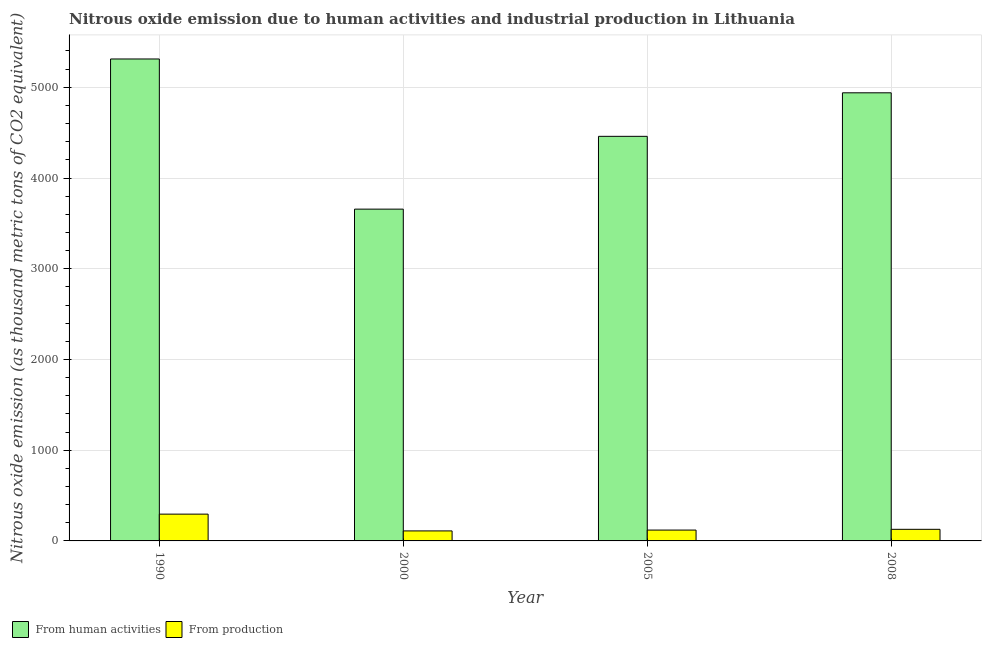How many different coloured bars are there?
Your response must be concise. 2. Are the number of bars per tick equal to the number of legend labels?
Offer a very short reply. Yes. How many bars are there on the 4th tick from the left?
Ensure brevity in your answer.  2. What is the label of the 4th group of bars from the left?
Give a very brief answer. 2008. In how many cases, is the number of bars for a given year not equal to the number of legend labels?
Give a very brief answer. 0. What is the amount of emissions generated from industries in 1990?
Offer a very short reply. 295.2. Across all years, what is the maximum amount of emissions from human activities?
Ensure brevity in your answer.  5312.1. Across all years, what is the minimum amount of emissions from human activities?
Provide a short and direct response. 3657. What is the total amount of emissions generated from industries in the graph?
Provide a short and direct response. 653. What is the difference between the amount of emissions generated from industries in 1990 and that in 2008?
Ensure brevity in your answer.  167.3. What is the difference between the amount of emissions generated from industries in 1990 and the amount of emissions from human activities in 2005?
Your answer should be compact. 175.6. What is the average amount of emissions from human activities per year?
Your answer should be compact. 4591.93. What is the ratio of the amount of emissions from human activities in 2005 to that in 2008?
Offer a terse response. 0.9. Is the amount of emissions from human activities in 2000 less than that in 2005?
Ensure brevity in your answer.  Yes. Is the difference between the amount of emissions from human activities in 1990 and 2005 greater than the difference between the amount of emissions generated from industries in 1990 and 2005?
Give a very brief answer. No. What is the difference between the highest and the second highest amount of emissions from human activities?
Make the answer very short. 372.9. What is the difference between the highest and the lowest amount of emissions from human activities?
Offer a terse response. 1655.1. Is the sum of the amount of emissions from human activities in 1990 and 2000 greater than the maximum amount of emissions generated from industries across all years?
Give a very brief answer. Yes. What does the 2nd bar from the left in 1990 represents?
Give a very brief answer. From production. What does the 1st bar from the right in 2008 represents?
Provide a short and direct response. From production. How many bars are there?
Offer a terse response. 8. Are all the bars in the graph horizontal?
Offer a very short reply. No. How are the legend labels stacked?
Ensure brevity in your answer.  Horizontal. What is the title of the graph?
Offer a terse response. Nitrous oxide emission due to human activities and industrial production in Lithuania. What is the label or title of the Y-axis?
Provide a short and direct response. Nitrous oxide emission (as thousand metric tons of CO2 equivalent). What is the Nitrous oxide emission (as thousand metric tons of CO2 equivalent) of From human activities in 1990?
Give a very brief answer. 5312.1. What is the Nitrous oxide emission (as thousand metric tons of CO2 equivalent) of From production in 1990?
Provide a succinct answer. 295.2. What is the Nitrous oxide emission (as thousand metric tons of CO2 equivalent) of From human activities in 2000?
Provide a succinct answer. 3657. What is the Nitrous oxide emission (as thousand metric tons of CO2 equivalent) of From production in 2000?
Make the answer very short. 110.3. What is the Nitrous oxide emission (as thousand metric tons of CO2 equivalent) in From human activities in 2005?
Your answer should be compact. 4459.4. What is the Nitrous oxide emission (as thousand metric tons of CO2 equivalent) in From production in 2005?
Provide a succinct answer. 119.6. What is the Nitrous oxide emission (as thousand metric tons of CO2 equivalent) in From human activities in 2008?
Provide a succinct answer. 4939.2. What is the Nitrous oxide emission (as thousand metric tons of CO2 equivalent) in From production in 2008?
Your response must be concise. 127.9. Across all years, what is the maximum Nitrous oxide emission (as thousand metric tons of CO2 equivalent) of From human activities?
Make the answer very short. 5312.1. Across all years, what is the maximum Nitrous oxide emission (as thousand metric tons of CO2 equivalent) in From production?
Keep it short and to the point. 295.2. Across all years, what is the minimum Nitrous oxide emission (as thousand metric tons of CO2 equivalent) in From human activities?
Offer a very short reply. 3657. Across all years, what is the minimum Nitrous oxide emission (as thousand metric tons of CO2 equivalent) of From production?
Provide a short and direct response. 110.3. What is the total Nitrous oxide emission (as thousand metric tons of CO2 equivalent) in From human activities in the graph?
Provide a succinct answer. 1.84e+04. What is the total Nitrous oxide emission (as thousand metric tons of CO2 equivalent) of From production in the graph?
Your answer should be very brief. 653. What is the difference between the Nitrous oxide emission (as thousand metric tons of CO2 equivalent) in From human activities in 1990 and that in 2000?
Your response must be concise. 1655.1. What is the difference between the Nitrous oxide emission (as thousand metric tons of CO2 equivalent) of From production in 1990 and that in 2000?
Provide a short and direct response. 184.9. What is the difference between the Nitrous oxide emission (as thousand metric tons of CO2 equivalent) in From human activities in 1990 and that in 2005?
Keep it short and to the point. 852.7. What is the difference between the Nitrous oxide emission (as thousand metric tons of CO2 equivalent) in From production in 1990 and that in 2005?
Your answer should be very brief. 175.6. What is the difference between the Nitrous oxide emission (as thousand metric tons of CO2 equivalent) in From human activities in 1990 and that in 2008?
Provide a short and direct response. 372.9. What is the difference between the Nitrous oxide emission (as thousand metric tons of CO2 equivalent) of From production in 1990 and that in 2008?
Your answer should be very brief. 167.3. What is the difference between the Nitrous oxide emission (as thousand metric tons of CO2 equivalent) in From human activities in 2000 and that in 2005?
Keep it short and to the point. -802.4. What is the difference between the Nitrous oxide emission (as thousand metric tons of CO2 equivalent) of From human activities in 2000 and that in 2008?
Your answer should be very brief. -1282.2. What is the difference between the Nitrous oxide emission (as thousand metric tons of CO2 equivalent) of From production in 2000 and that in 2008?
Your answer should be very brief. -17.6. What is the difference between the Nitrous oxide emission (as thousand metric tons of CO2 equivalent) in From human activities in 2005 and that in 2008?
Offer a very short reply. -479.8. What is the difference between the Nitrous oxide emission (as thousand metric tons of CO2 equivalent) of From production in 2005 and that in 2008?
Your answer should be very brief. -8.3. What is the difference between the Nitrous oxide emission (as thousand metric tons of CO2 equivalent) in From human activities in 1990 and the Nitrous oxide emission (as thousand metric tons of CO2 equivalent) in From production in 2000?
Provide a succinct answer. 5201.8. What is the difference between the Nitrous oxide emission (as thousand metric tons of CO2 equivalent) of From human activities in 1990 and the Nitrous oxide emission (as thousand metric tons of CO2 equivalent) of From production in 2005?
Offer a very short reply. 5192.5. What is the difference between the Nitrous oxide emission (as thousand metric tons of CO2 equivalent) of From human activities in 1990 and the Nitrous oxide emission (as thousand metric tons of CO2 equivalent) of From production in 2008?
Give a very brief answer. 5184.2. What is the difference between the Nitrous oxide emission (as thousand metric tons of CO2 equivalent) of From human activities in 2000 and the Nitrous oxide emission (as thousand metric tons of CO2 equivalent) of From production in 2005?
Offer a terse response. 3537.4. What is the difference between the Nitrous oxide emission (as thousand metric tons of CO2 equivalent) of From human activities in 2000 and the Nitrous oxide emission (as thousand metric tons of CO2 equivalent) of From production in 2008?
Keep it short and to the point. 3529.1. What is the difference between the Nitrous oxide emission (as thousand metric tons of CO2 equivalent) of From human activities in 2005 and the Nitrous oxide emission (as thousand metric tons of CO2 equivalent) of From production in 2008?
Your answer should be very brief. 4331.5. What is the average Nitrous oxide emission (as thousand metric tons of CO2 equivalent) of From human activities per year?
Your answer should be compact. 4591.93. What is the average Nitrous oxide emission (as thousand metric tons of CO2 equivalent) in From production per year?
Keep it short and to the point. 163.25. In the year 1990, what is the difference between the Nitrous oxide emission (as thousand metric tons of CO2 equivalent) in From human activities and Nitrous oxide emission (as thousand metric tons of CO2 equivalent) in From production?
Your answer should be compact. 5016.9. In the year 2000, what is the difference between the Nitrous oxide emission (as thousand metric tons of CO2 equivalent) in From human activities and Nitrous oxide emission (as thousand metric tons of CO2 equivalent) in From production?
Provide a succinct answer. 3546.7. In the year 2005, what is the difference between the Nitrous oxide emission (as thousand metric tons of CO2 equivalent) of From human activities and Nitrous oxide emission (as thousand metric tons of CO2 equivalent) of From production?
Your response must be concise. 4339.8. In the year 2008, what is the difference between the Nitrous oxide emission (as thousand metric tons of CO2 equivalent) of From human activities and Nitrous oxide emission (as thousand metric tons of CO2 equivalent) of From production?
Your response must be concise. 4811.3. What is the ratio of the Nitrous oxide emission (as thousand metric tons of CO2 equivalent) in From human activities in 1990 to that in 2000?
Your answer should be very brief. 1.45. What is the ratio of the Nitrous oxide emission (as thousand metric tons of CO2 equivalent) in From production in 1990 to that in 2000?
Your answer should be compact. 2.68. What is the ratio of the Nitrous oxide emission (as thousand metric tons of CO2 equivalent) of From human activities in 1990 to that in 2005?
Your answer should be very brief. 1.19. What is the ratio of the Nitrous oxide emission (as thousand metric tons of CO2 equivalent) in From production in 1990 to that in 2005?
Your answer should be compact. 2.47. What is the ratio of the Nitrous oxide emission (as thousand metric tons of CO2 equivalent) in From human activities in 1990 to that in 2008?
Give a very brief answer. 1.08. What is the ratio of the Nitrous oxide emission (as thousand metric tons of CO2 equivalent) of From production in 1990 to that in 2008?
Offer a terse response. 2.31. What is the ratio of the Nitrous oxide emission (as thousand metric tons of CO2 equivalent) of From human activities in 2000 to that in 2005?
Provide a succinct answer. 0.82. What is the ratio of the Nitrous oxide emission (as thousand metric tons of CO2 equivalent) in From production in 2000 to that in 2005?
Your answer should be compact. 0.92. What is the ratio of the Nitrous oxide emission (as thousand metric tons of CO2 equivalent) in From human activities in 2000 to that in 2008?
Your response must be concise. 0.74. What is the ratio of the Nitrous oxide emission (as thousand metric tons of CO2 equivalent) of From production in 2000 to that in 2008?
Provide a short and direct response. 0.86. What is the ratio of the Nitrous oxide emission (as thousand metric tons of CO2 equivalent) in From human activities in 2005 to that in 2008?
Keep it short and to the point. 0.9. What is the ratio of the Nitrous oxide emission (as thousand metric tons of CO2 equivalent) of From production in 2005 to that in 2008?
Offer a very short reply. 0.94. What is the difference between the highest and the second highest Nitrous oxide emission (as thousand metric tons of CO2 equivalent) of From human activities?
Make the answer very short. 372.9. What is the difference between the highest and the second highest Nitrous oxide emission (as thousand metric tons of CO2 equivalent) in From production?
Offer a terse response. 167.3. What is the difference between the highest and the lowest Nitrous oxide emission (as thousand metric tons of CO2 equivalent) in From human activities?
Keep it short and to the point. 1655.1. What is the difference between the highest and the lowest Nitrous oxide emission (as thousand metric tons of CO2 equivalent) in From production?
Ensure brevity in your answer.  184.9. 